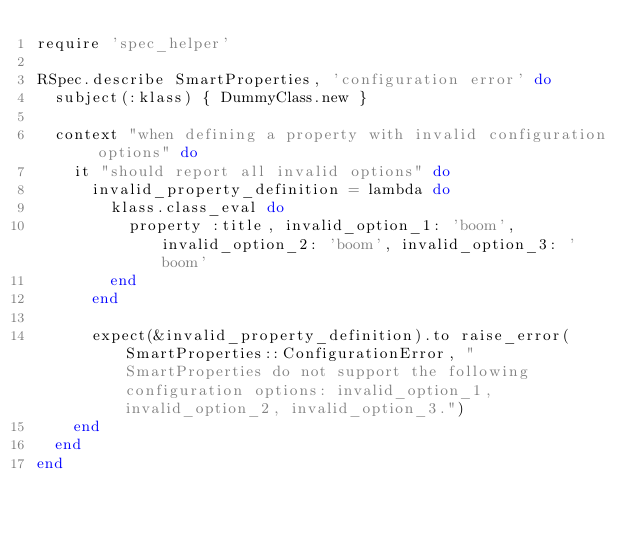<code> <loc_0><loc_0><loc_500><loc_500><_Ruby_>require 'spec_helper'

RSpec.describe SmartProperties, 'configuration error' do
  subject(:klass) { DummyClass.new }

  context "when defining a property with invalid configuration options" do
    it "should report all invalid options" do
      invalid_property_definition = lambda do
        klass.class_eval do
          property :title, invalid_option_1: 'boom', invalid_option_2: 'boom', invalid_option_3: 'boom'
        end
      end

      expect(&invalid_property_definition).to raise_error(SmartProperties::ConfigurationError, "SmartProperties do not support the following configuration options: invalid_option_1, invalid_option_2, invalid_option_3.")
    end
  end
end
</code> 